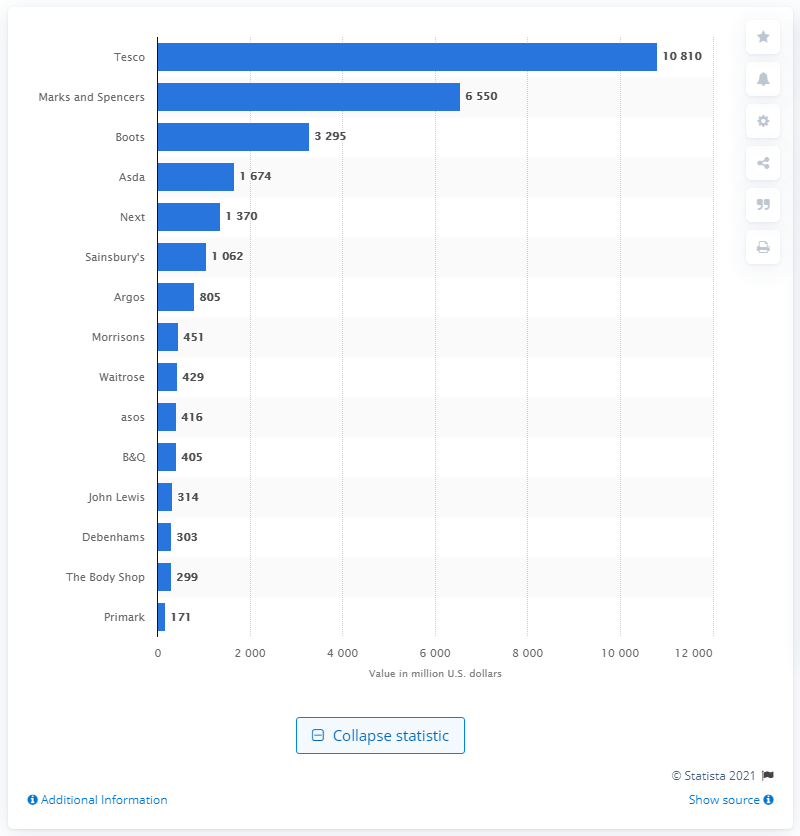List a handful of essential elements in this visual. In 2013, Tesco was regarded as the most valuable retail brand in the United Kingdom. In 2013, the value of Marks and Spencer was 6,550. 